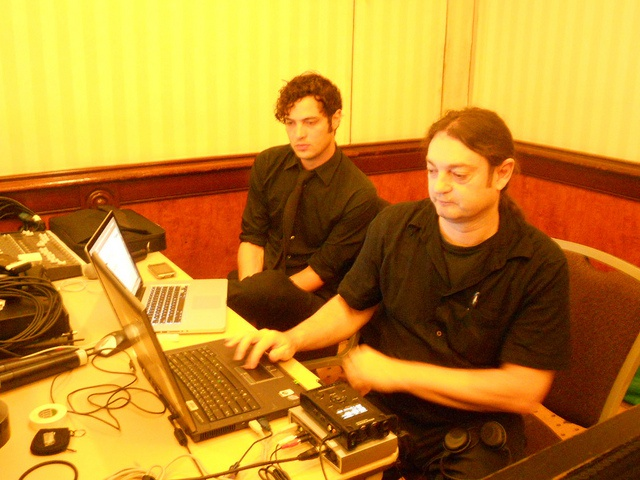Describe the objects in this image and their specific colors. I can see people in yellow, black, maroon, orange, and gold tones, people in yellow, maroon, orange, and brown tones, laptop in yellow, red, orange, and maroon tones, chair in yellow, maroon, red, and orange tones, and laptop in yellow, khaki, ivory, and orange tones in this image. 